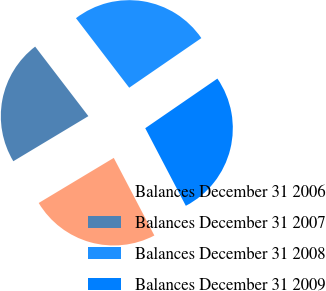Convert chart to OTSL. <chart><loc_0><loc_0><loc_500><loc_500><pie_chart><fcel>Balances December 31 2006<fcel>Balances December 31 2007<fcel>Balances December 31 2008<fcel>Balances December 31 2009<nl><fcel>24.06%<fcel>23.21%<fcel>25.81%<fcel>26.92%<nl></chart> 